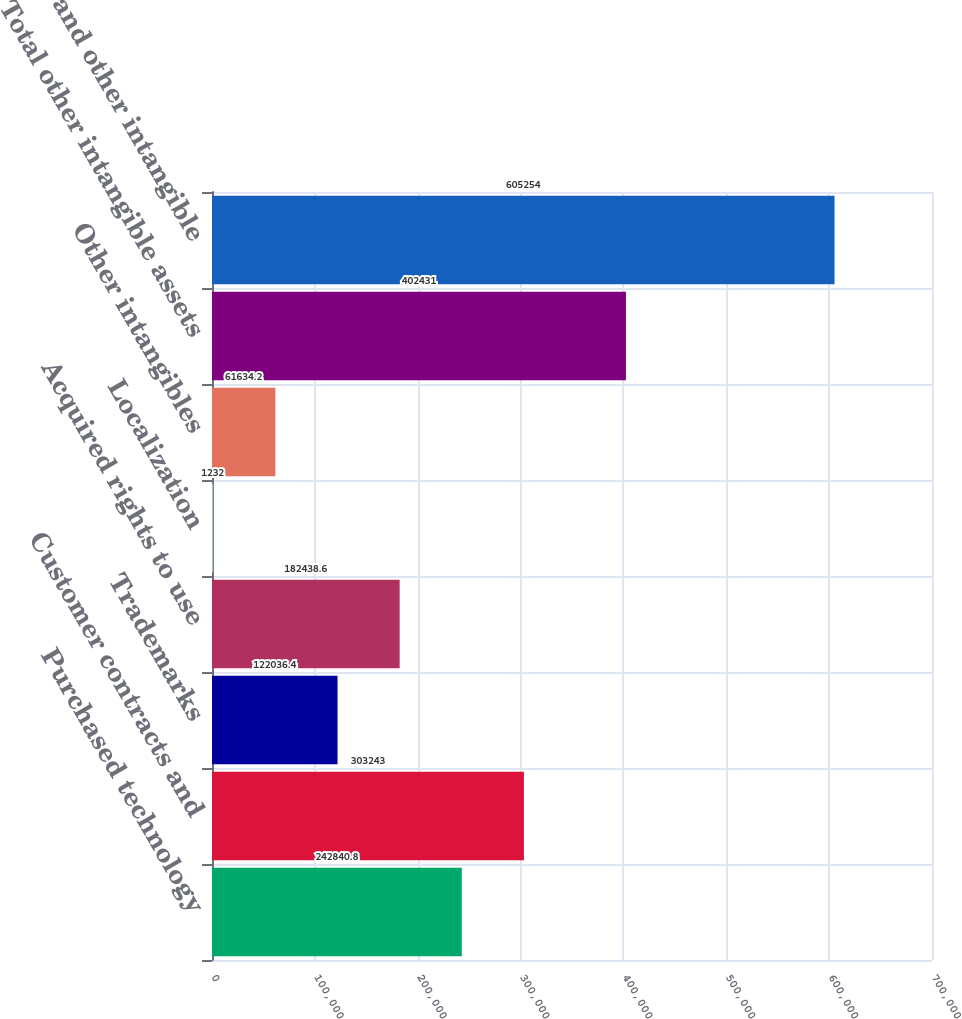Convert chart. <chart><loc_0><loc_0><loc_500><loc_500><bar_chart><fcel>Purchased technology<fcel>Customer contracts and<fcel>Trademarks<fcel>Acquired rights to use<fcel>Localization<fcel>Other intangibles<fcel>Total other intangible assets<fcel>Purchased and other intangible<nl><fcel>242841<fcel>303243<fcel>122036<fcel>182439<fcel>1232<fcel>61634.2<fcel>402431<fcel>605254<nl></chart> 